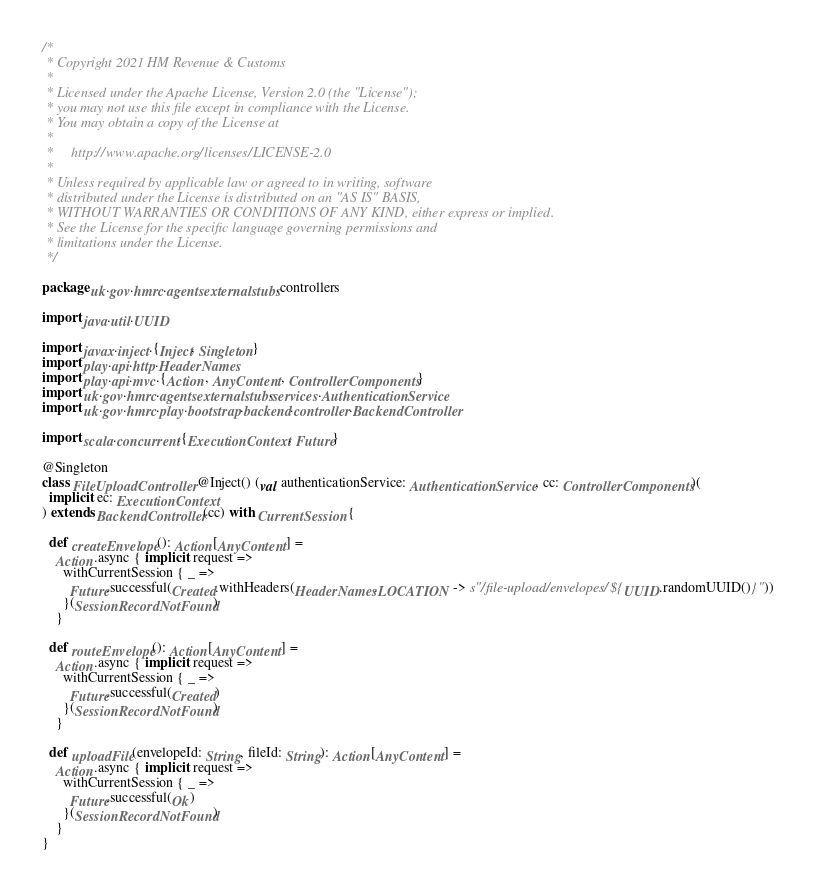Convert code to text. <code><loc_0><loc_0><loc_500><loc_500><_Scala_>/*
 * Copyright 2021 HM Revenue & Customs
 *
 * Licensed under the Apache License, Version 2.0 (the "License");
 * you may not use this file except in compliance with the License.
 * You may obtain a copy of the License at
 *
 *     http://www.apache.org/licenses/LICENSE-2.0
 *
 * Unless required by applicable law or agreed to in writing, software
 * distributed under the License is distributed on an "AS IS" BASIS,
 * WITHOUT WARRANTIES OR CONDITIONS OF ANY KIND, either express or implied.
 * See the License for the specific language governing permissions and
 * limitations under the License.
 */

package uk.gov.hmrc.agentsexternalstubs.controllers

import java.util.UUID

import javax.inject.{Inject, Singleton}
import play.api.http.HeaderNames
import play.api.mvc.{Action, AnyContent, ControllerComponents}
import uk.gov.hmrc.agentsexternalstubs.services.AuthenticationService
import uk.gov.hmrc.play.bootstrap.backend.controller.BackendController

import scala.concurrent.{ExecutionContext, Future}

@Singleton
class FileUploadController @Inject() (val authenticationService: AuthenticationService, cc: ControllerComponents)(
  implicit ec: ExecutionContext
) extends BackendController(cc) with CurrentSession {

  def createEnvelope(): Action[AnyContent] =
    Action.async { implicit request =>
      withCurrentSession { _ =>
        Future.successful(Created.withHeaders(HeaderNames.LOCATION -> s"/file-upload/envelopes/${UUID.randomUUID()}"))
      }(SessionRecordNotFound)
    }

  def routeEnvelope(): Action[AnyContent] =
    Action.async { implicit request =>
      withCurrentSession { _ =>
        Future.successful(Created)
      }(SessionRecordNotFound)
    }

  def uploadFile(envelopeId: String, fileId: String): Action[AnyContent] =
    Action.async { implicit request =>
      withCurrentSession { _ =>
        Future.successful(Ok)
      }(SessionRecordNotFound)
    }
}
</code> 